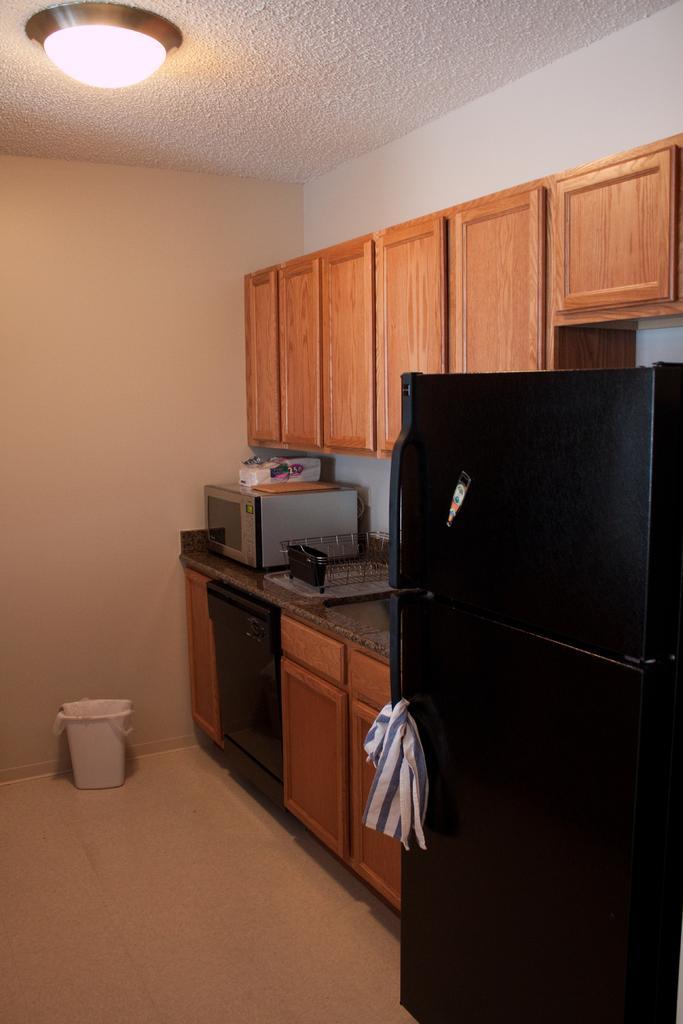Describe this image in one or two sentences. In this image we can see an oven and some objects placed on the countertop. We can also see a refrigerator, cupboards, a trash bin, a wall and a ceiling light to a roof. 